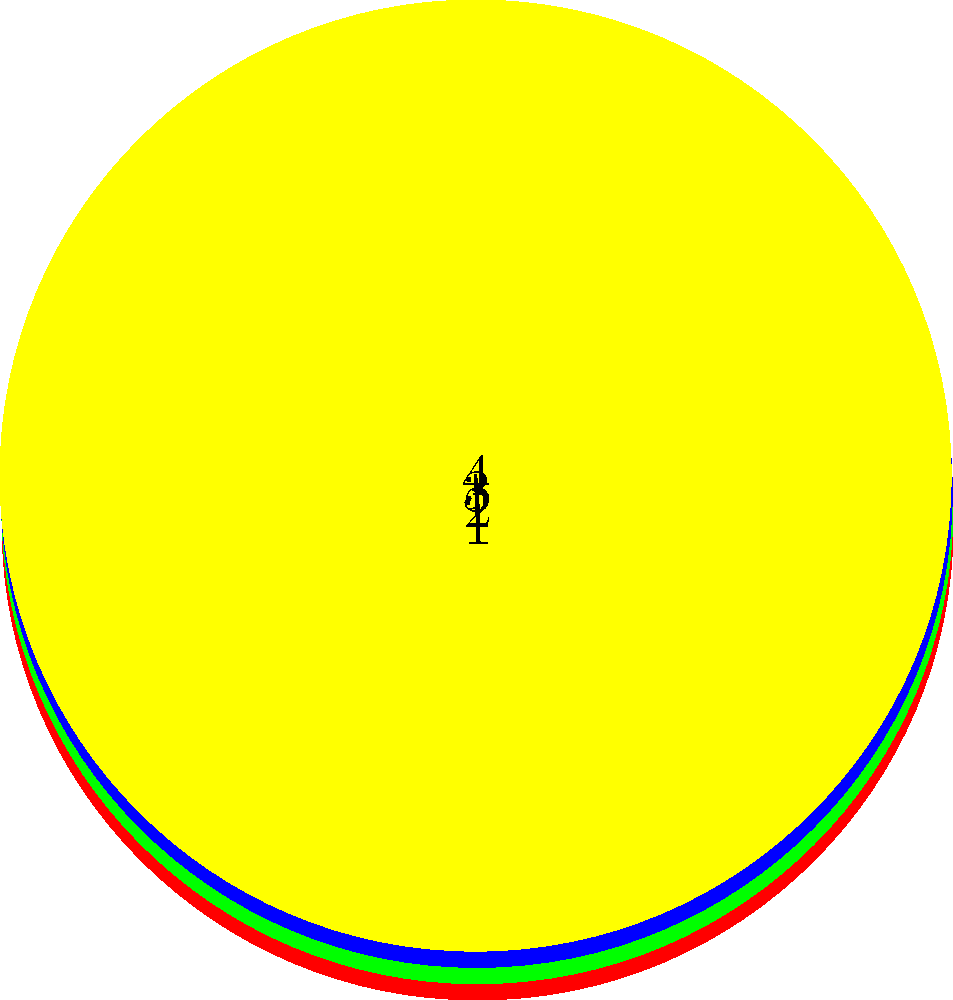As a graphic designer working with a market researcher, you're tasked with creating a visual representation of a map coloring problem. The diagram shows four regions that need to be colored such that no adjacent regions share the same color. Given that you have access to red, green, blue, and yellow colors, what is the minimum number of colors needed to properly color this map? To solve this problem, we'll use the concept of graph coloring from graph theory. Let's approach this step-by-step:

1. Analyze the map structure:
   - The map consists of 4 regions, each adjacent to the other three.
   - This forms a complete graph with 4 vertices.

2. Consider the coloring constraint:
   - Adjacent regions must have different colors.
   - In this case, every region is adjacent to every other region.

3. Apply the graph coloring theorem:
   - For a complete graph with $n$ vertices, the chromatic number (minimum number of colors needed) is $n$.
   - In this case, $n = 4$.

4. Verify the solution:
   - We need to assign a unique color to each region.
   - With 4 colors (red, green, blue, yellow), we can assign one to each region.
   - Any arrangement where each region has a different color is valid.

5. Consider alternatives:
   - Using fewer than 4 colors would result in at least two adjacent regions sharing a color, violating the constraint.

Therefore, the minimum number of colors needed to properly color this map is 4.
Answer: 4 colors 